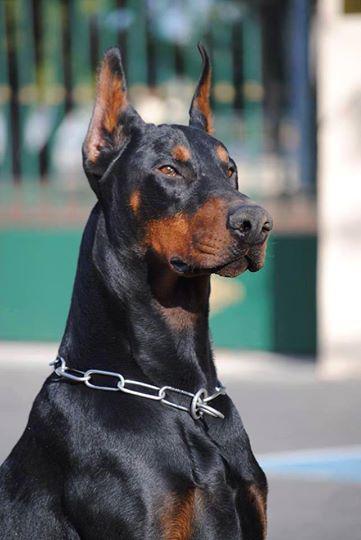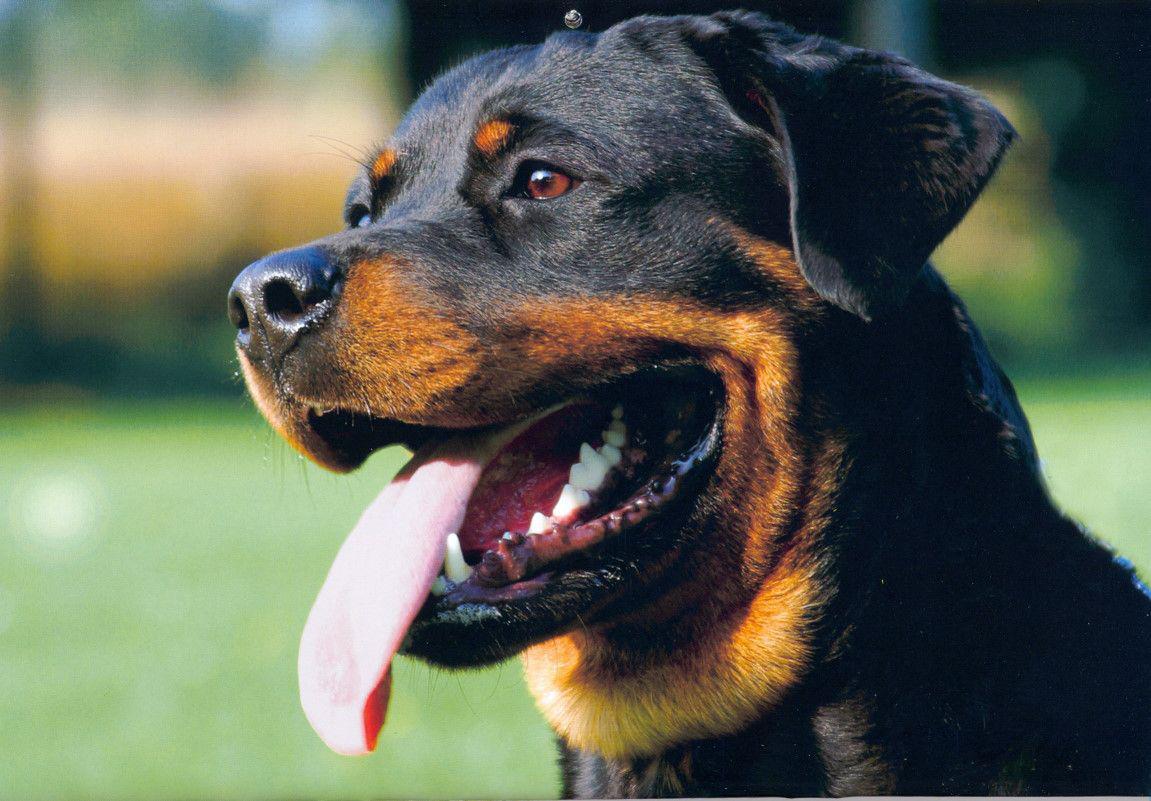The first image is the image on the left, the second image is the image on the right. Assess this claim about the two images: "In the image on the right, a dog is looking to the left.". Correct or not? Answer yes or no. Yes. 